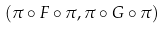Convert formula to latex. <formula><loc_0><loc_0><loc_500><loc_500>( \pi \circ F \circ \pi , \pi \circ G \circ \pi )</formula> 